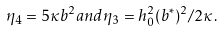<formula> <loc_0><loc_0><loc_500><loc_500>\eta _ { 4 } = 5 \kappa b ^ { 2 } a n d \eta _ { 3 } = h _ { 0 } ^ { 2 } ( b ^ { \ast } ) ^ { 2 } / 2 \kappa .</formula> 